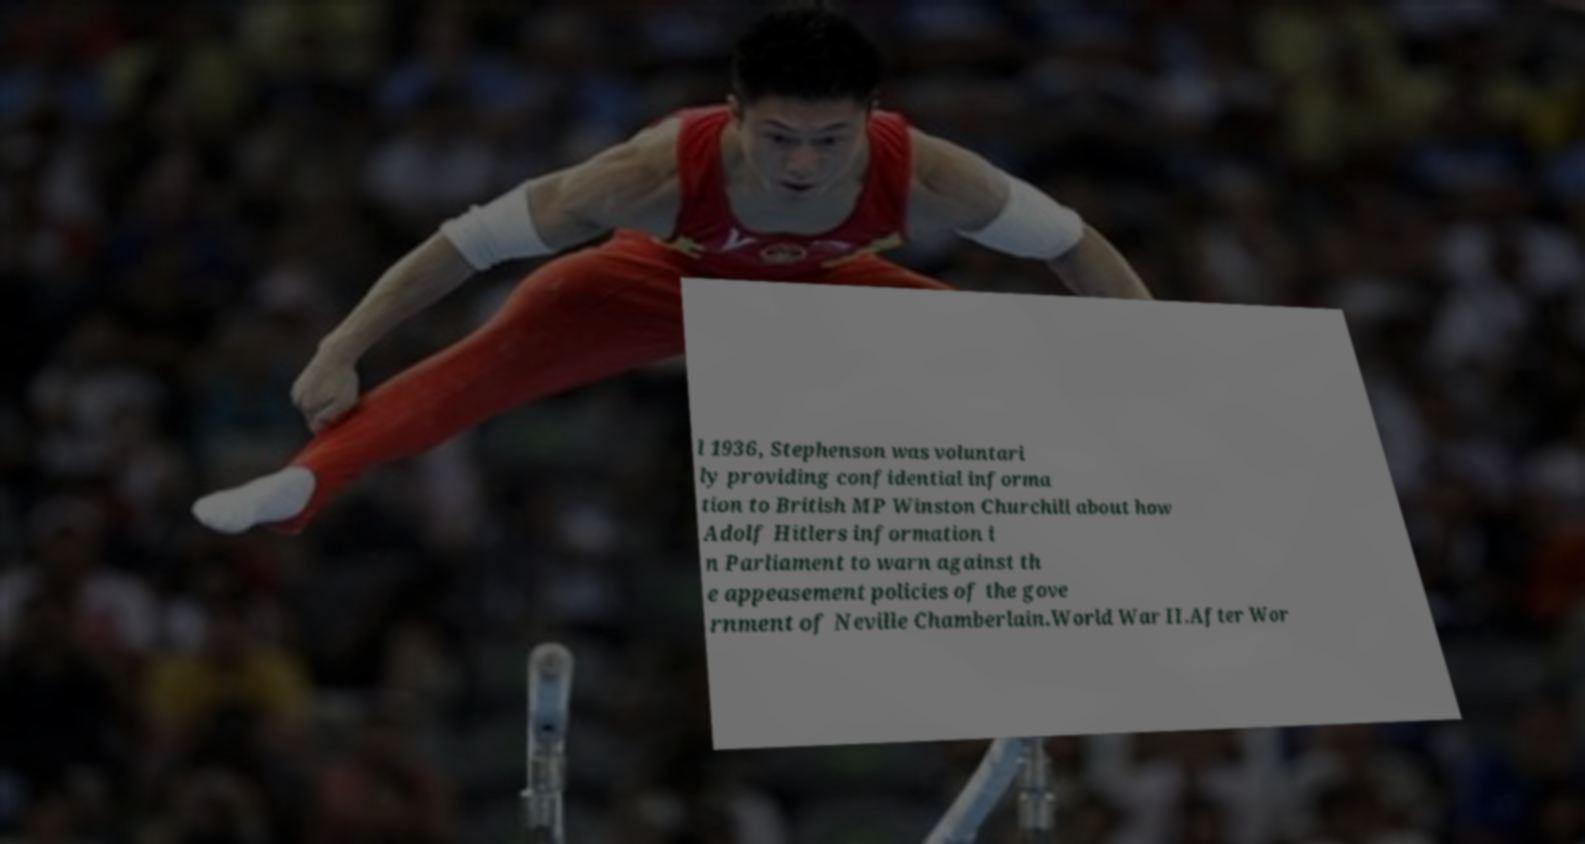Could you assist in decoding the text presented in this image and type it out clearly? l 1936, Stephenson was voluntari ly providing confidential informa tion to British MP Winston Churchill about how Adolf Hitlers information i n Parliament to warn against th e appeasement policies of the gove rnment of Neville Chamberlain.World War II.After Wor 